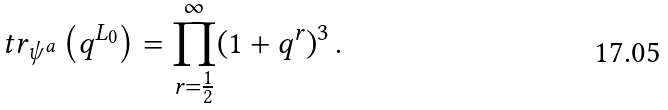<formula> <loc_0><loc_0><loc_500><loc_500>\ t r _ { \psi ^ { a } } \left ( q ^ { L _ { 0 } } \right ) = \prod _ { r = \frac { 1 } { 2 } } ^ { \infty } ( 1 + q ^ { r } ) ^ { 3 } \, .</formula> 